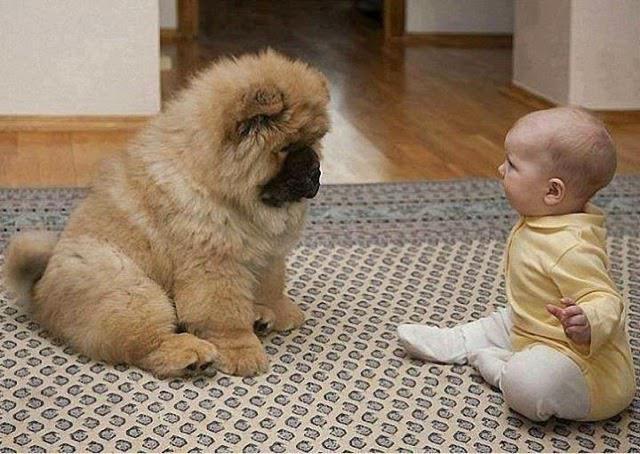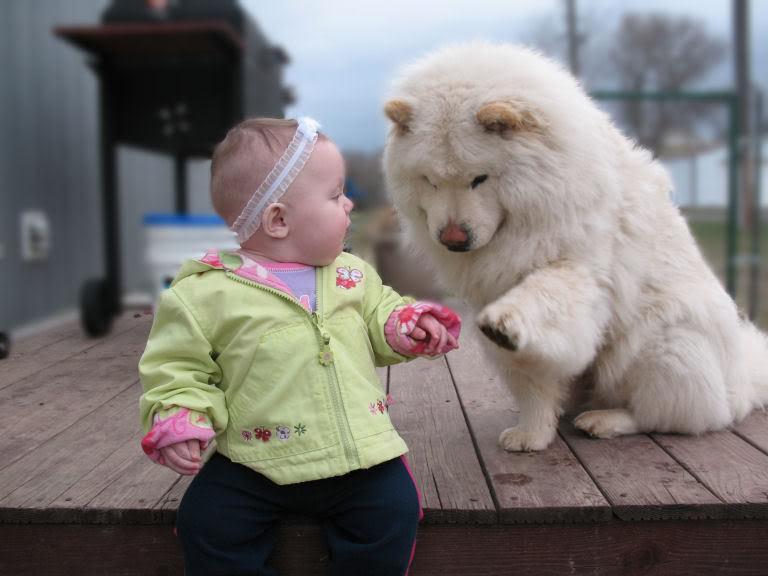The first image is the image on the left, the second image is the image on the right. Considering the images on both sides, is "The right image shows a baby sitting to the right of an adult chow, and the left image shows one forward-turned cream-colored chow puppy." valid? Answer yes or no. No. 